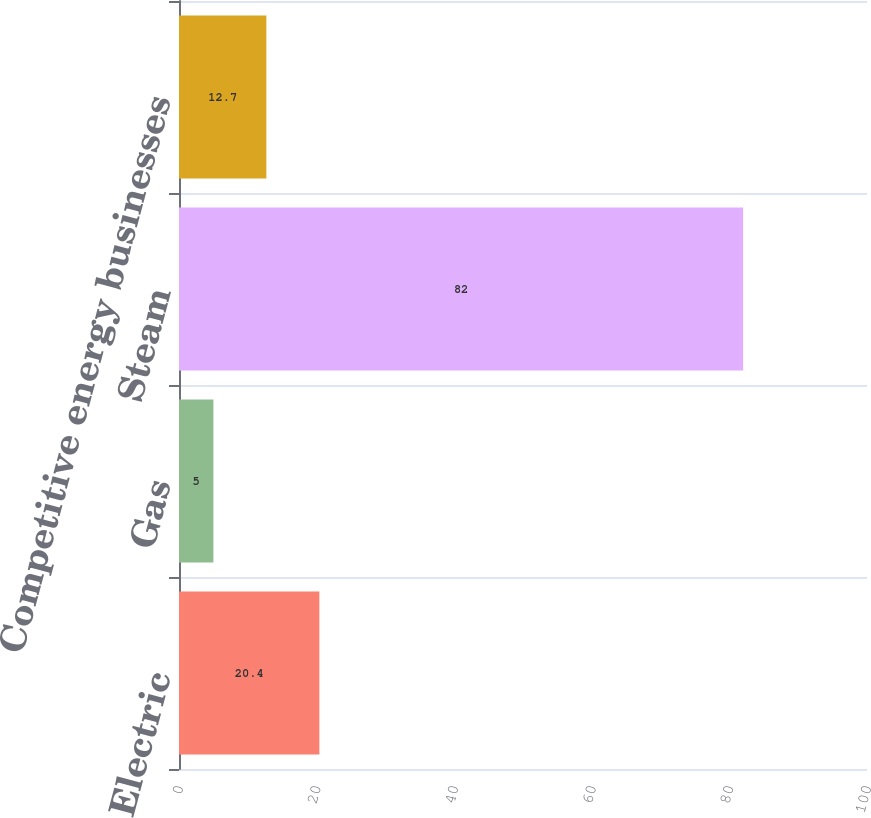Convert chart. <chart><loc_0><loc_0><loc_500><loc_500><bar_chart><fcel>Electric<fcel>Gas<fcel>Steam<fcel>Competitive energy businesses<nl><fcel>20.4<fcel>5<fcel>82<fcel>12.7<nl></chart> 